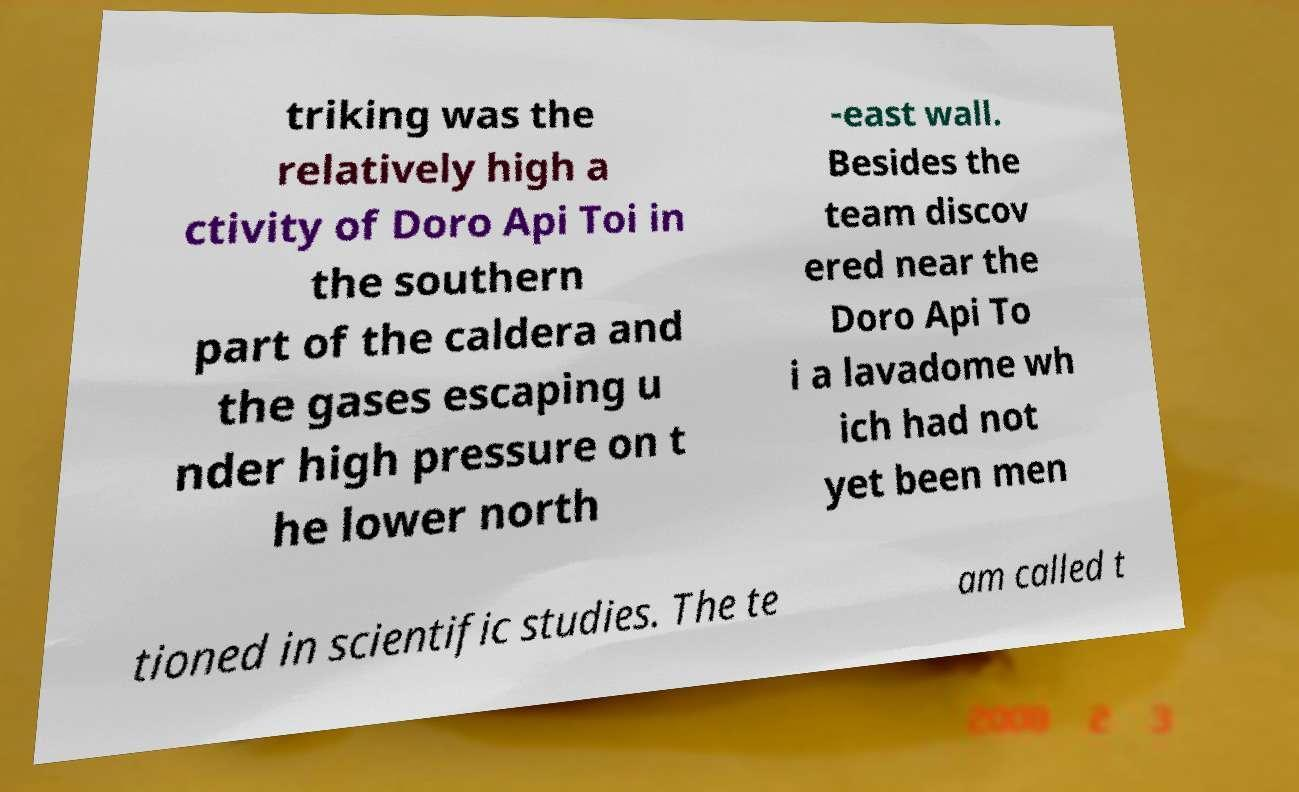Can you accurately transcribe the text from the provided image for me? triking was the relatively high a ctivity of Doro Api Toi in the southern part of the caldera and the gases escaping u nder high pressure on t he lower north -east wall. Besides the team discov ered near the Doro Api To i a lavadome wh ich had not yet been men tioned in scientific studies. The te am called t 